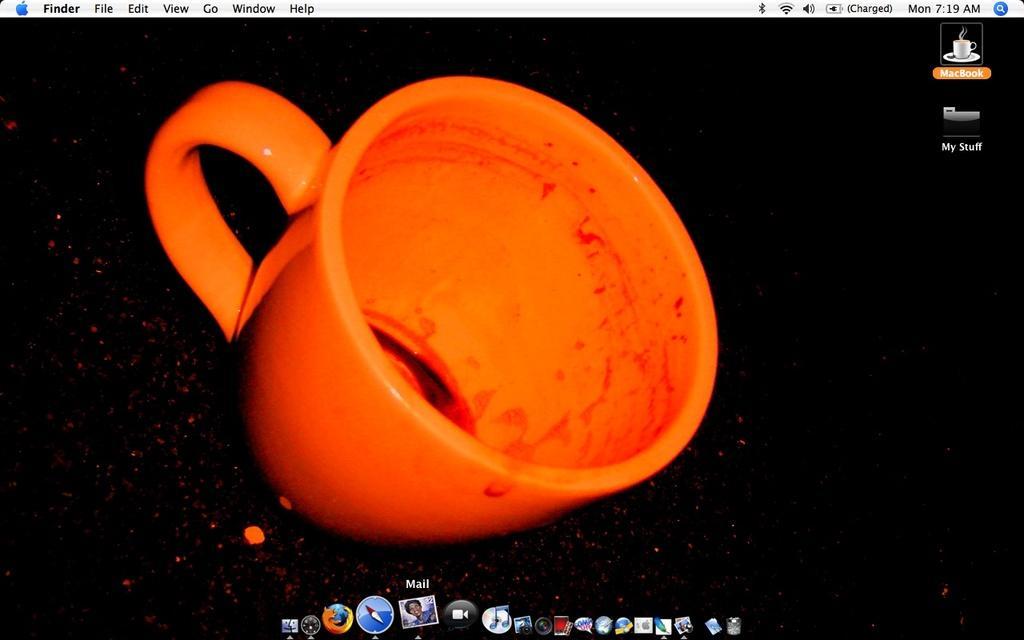Describe this image in one or two sentences. In this image we can see a background of a monitor screen containing a used cup on the table. We can also see some applications, time and day in this image. 